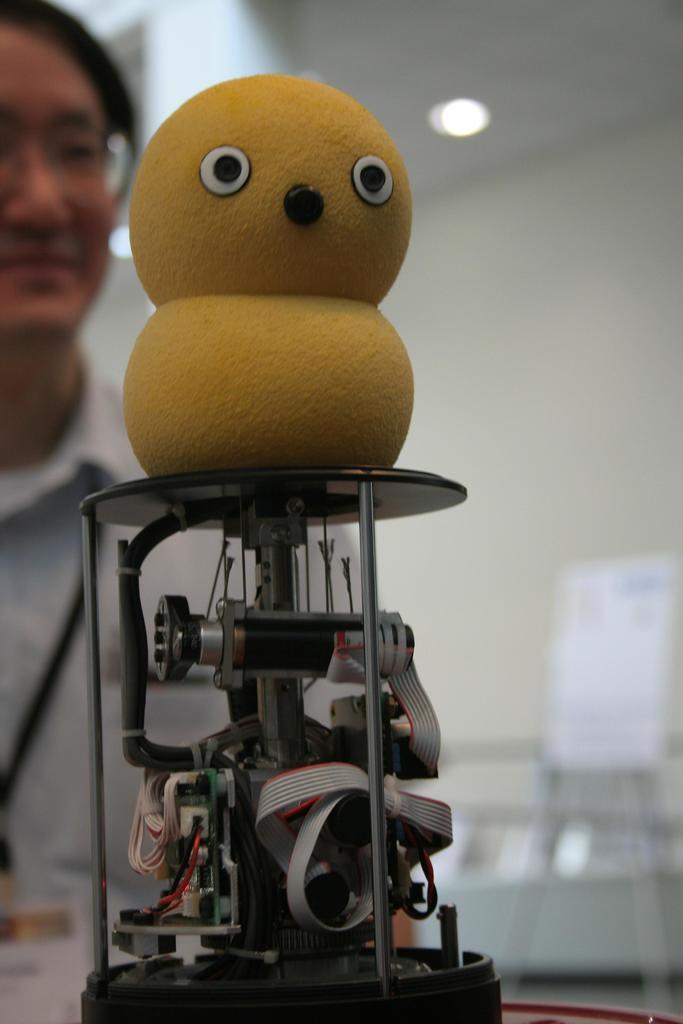What is the main object in the image? There is a machine in the image. What additional object can be seen above the machine? There is a duck toy above the machine. Can you describe the person visible in the image? There is a person visible in the image wearing a white shirt. What type of lighting is present in the image? There is a light over the ceiling in the image. What type of disease is the person in the image suffering from? There is no indication of any disease in the image, and the person's health is not mentioned. What type of bag is the person carrying in the image? There is no bag visible in the image. 